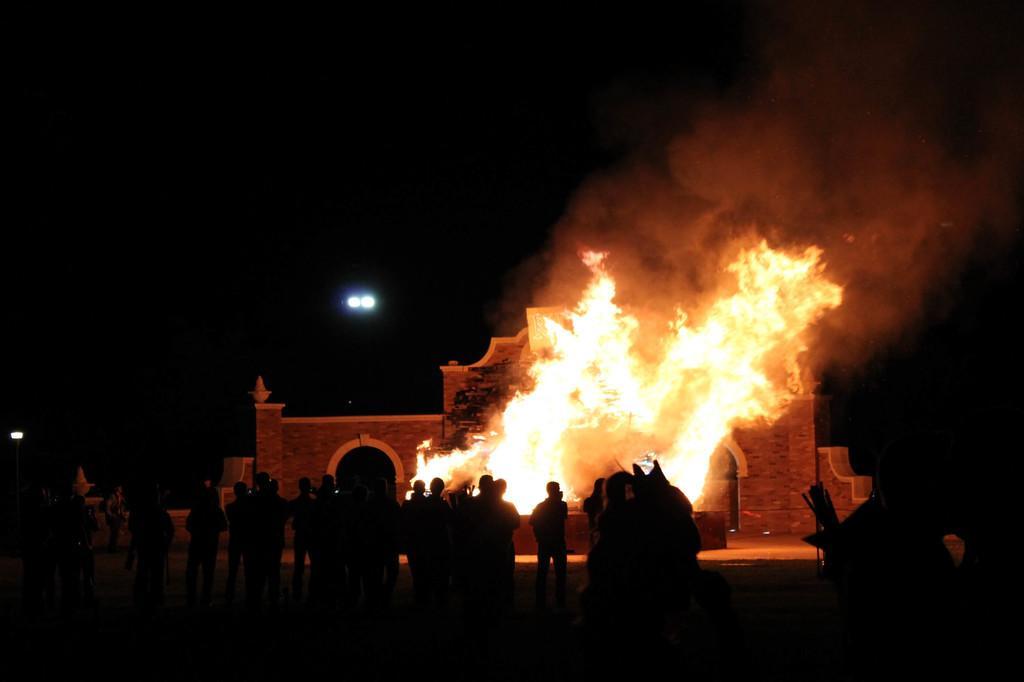Could you give a brief overview of what you see in this image? In this image , in the foreground there are people standing and in the middle there is a fire burning. 